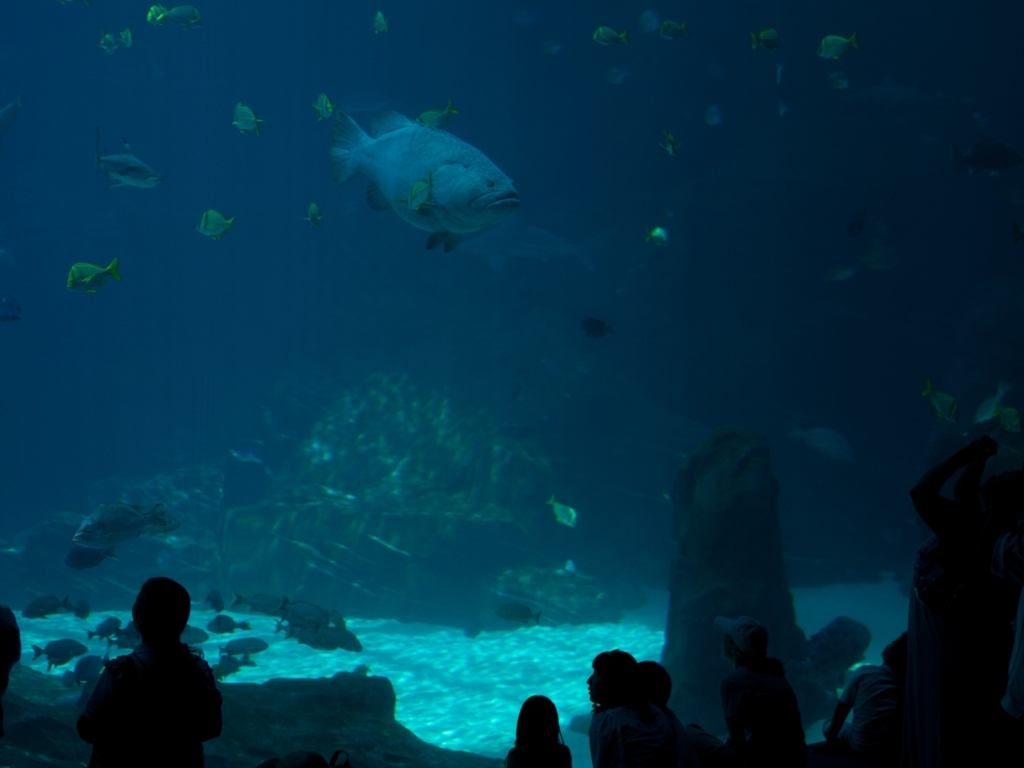What emotions does this image evoke? This image evokes a sense of tranquility and wonder. The soft blue tones and the presence of marine life create a calming effect, while the viewers' silhouettes against the large aquarium tank add a sense of scale and amazement. The beauty of the underwater environment is highlighted, which can inspire feelings of both relaxation and curiosity in the observer. How might this image be relevant to discussions on conservation? Aquariums like the one in this image play a significant role in conservation efforts by raising public awareness about marine biodiversity and the importance of protecting ocean habitats. By bringing people face-to-face with the splendor of underwater life, it can foster a deeper appreciation for these ecosystems and encourage actions to preserve them for future generations. 